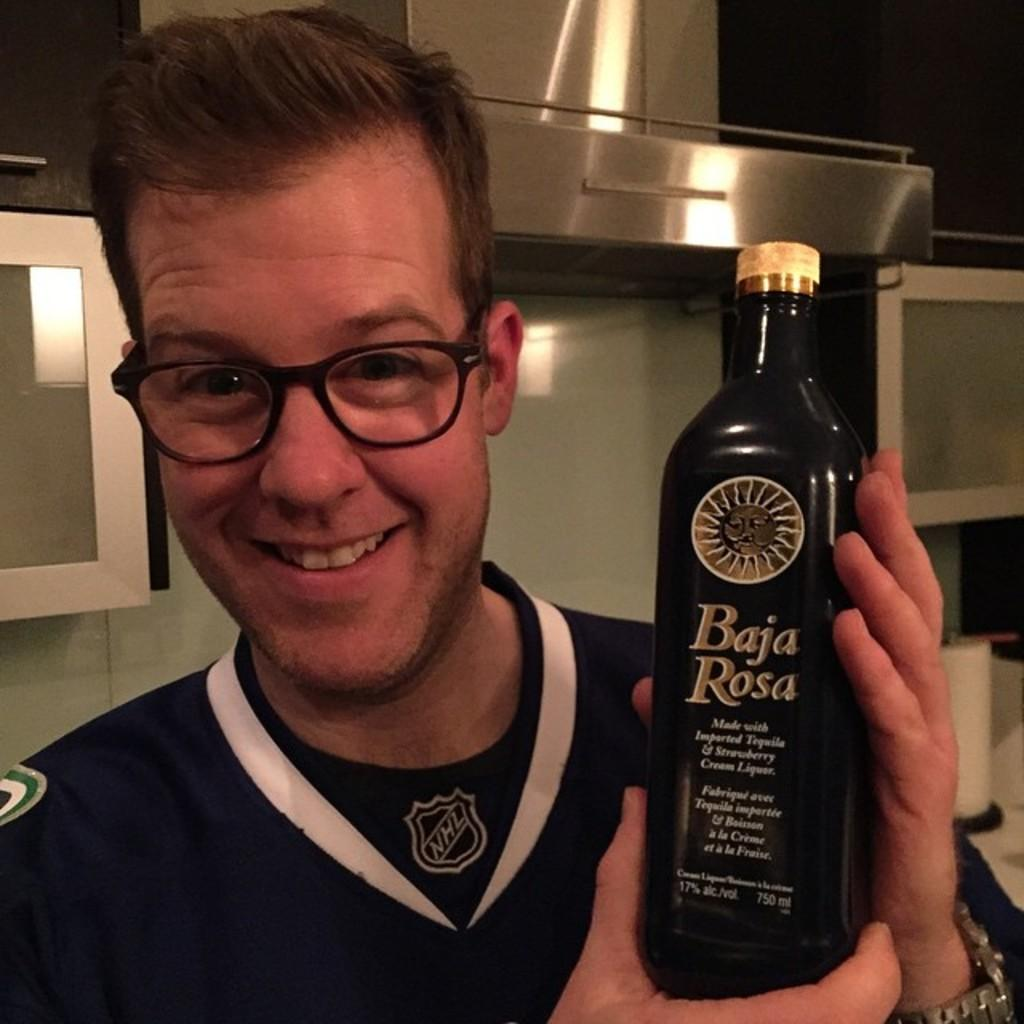<image>
Present a compact description of the photo's key features. Guy in a hockey jersey holding a bottle of Baja Rosa. 